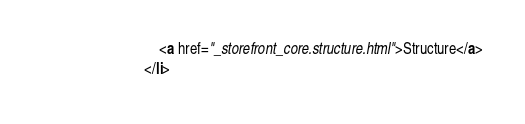<code> <loc_0><loc_0><loc_500><loc_500><_HTML_>								<a href="_storefront_core.structure.html">Structure</a>
							</li></code> 